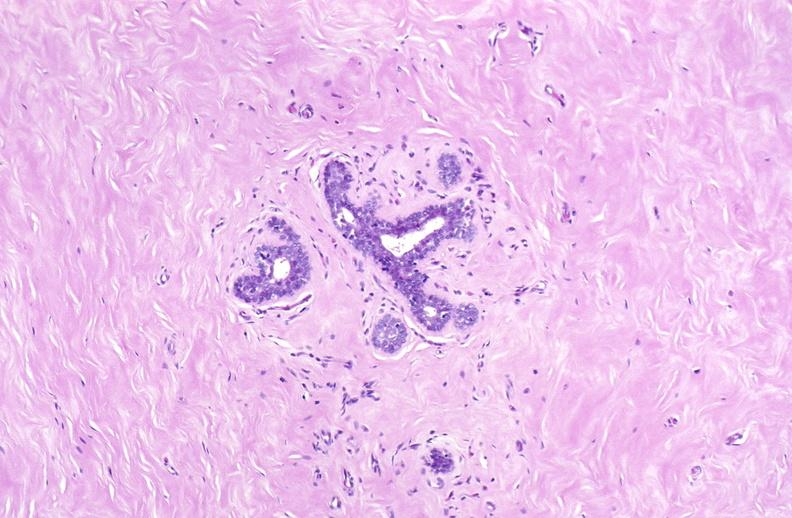does fibrinous peritonitis show breast, fibroadenoma?
Answer the question using a single word or phrase. No 